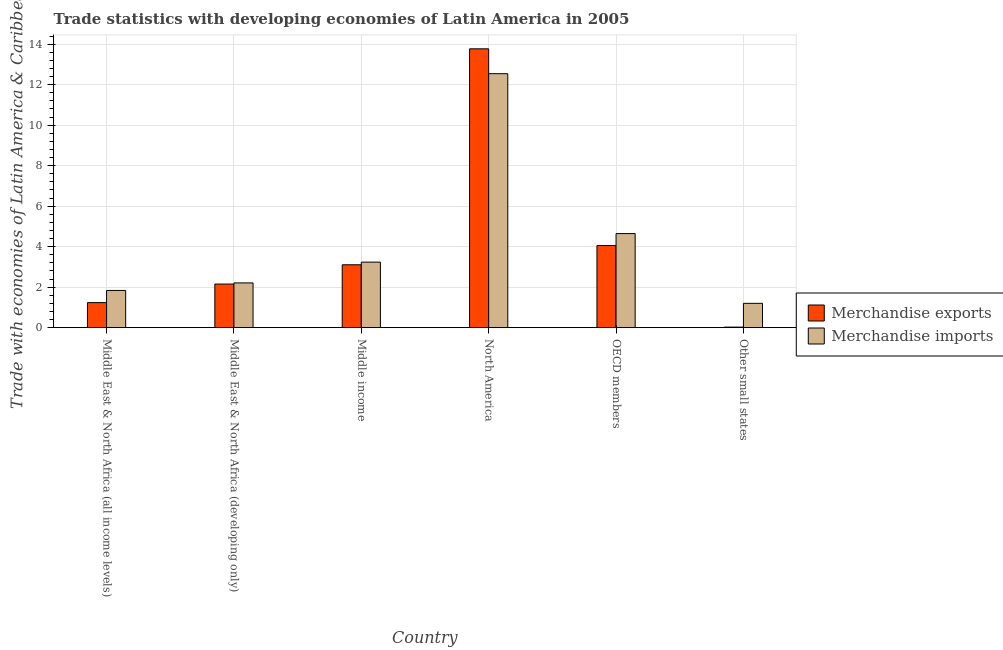How many groups of bars are there?
Your response must be concise. 6. Are the number of bars per tick equal to the number of legend labels?
Keep it short and to the point. Yes. Are the number of bars on each tick of the X-axis equal?
Make the answer very short. Yes. How many bars are there on the 4th tick from the left?
Give a very brief answer. 2. How many bars are there on the 1st tick from the right?
Your answer should be compact. 2. What is the label of the 6th group of bars from the left?
Offer a terse response. Other small states. What is the merchandise exports in Middle East & North Africa (all income levels)?
Provide a succinct answer. 1.24. Across all countries, what is the maximum merchandise exports?
Offer a terse response. 13.77. Across all countries, what is the minimum merchandise imports?
Keep it short and to the point. 1.2. In which country was the merchandise exports maximum?
Your response must be concise. North America. In which country was the merchandise imports minimum?
Keep it short and to the point. Other small states. What is the total merchandise exports in the graph?
Make the answer very short. 24.35. What is the difference between the merchandise exports in Middle East & North Africa (developing only) and that in Middle income?
Provide a succinct answer. -0.95. What is the difference between the merchandise exports in OECD members and the merchandise imports in North America?
Make the answer very short. -8.48. What is the average merchandise exports per country?
Ensure brevity in your answer.  4.06. What is the difference between the merchandise imports and merchandise exports in Middle East & North Africa (all income levels)?
Offer a terse response. 0.6. In how many countries, is the merchandise imports greater than 4 %?
Your answer should be very brief. 2. What is the ratio of the merchandise imports in Middle East & North Africa (all income levels) to that in Middle East & North Africa (developing only)?
Make the answer very short. 0.83. Is the difference between the merchandise imports in North America and Other small states greater than the difference between the merchandise exports in North America and Other small states?
Offer a terse response. No. What is the difference between the highest and the second highest merchandise imports?
Keep it short and to the point. 7.9. What is the difference between the highest and the lowest merchandise imports?
Make the answer very short. 11.34. In how many countries, is the merchandise imports greater than the average merchandise imports taken over all countries?
Your answer should be very brief. 2. Is the sum of the merchandise exports in Middle East & North Africa (developing only) and North America greater than the maximum merchandise imports across all countries?
Your answer should be very brief. Yes. What does the 1st bar from the left in OECD members represents?
Provide a succinct answer. Merchandise exports. What does the 2nd bar from the right in Middle income represents?
Ensure brevity in your answer.  Merchandise exports. How many bars are there?
Offer a terse response. 12. Are all the bars in the graph horizontal?
Give a very brief answer. No. How many countries are there in the graph?
Ensure brevity in your answer.  6. Does the graph contain any zero values?
Give a very brief answer. No. What is the title of the graph?
Your answer should be very brief. Trade statistics with developing economies of Latin America in 2005. Does "Goods and services" appear as one of the legend labels in the graph?
Give a very brief answer. No. What is the label or title of the X-axis?
Provide a succinct answer. Country. What is the label or title of the Y-axis?
Your response must be concise. Trade with economies of Latin America & Caribbean(%). What is the Trade with economies of Latin America & Caribbean(%) in Merchandise exports in Middle East & North Africa (all income levels)?
Provide a short and direct response. 1.24. What is the Trade with economies of Latin America & Caribbean(%) of Merchandise imports in Middle East & North Africa (all income levels)?
Your answer should be very brief. 1.84. What is the Trade with economies of Latin America & Caribbean(%) of Merchandise exports in Middle East & North Africa (developing only)?
Your response must be concise. 2.15. What is the Trade with economies of Latin America & Caribbean(%) in Merchandise imports in Middle East & North Africa (developing only)?
Provide a short and direct response. 2.21. What is the Trade with economies of Latin America & Caribbean(%) of Merchandise exports in Middle income?
Ensure brevity in your answer.  3.11. What is the Trade with economies of Latin America & Caribbean(%) in Merchandise imports in Middle income?
Offer a terse response. 3.24. What is the Trade with economies of Latin America & Caribbean(%) of Merchandise exports in North America?
Offer a very short reply. 13.77. What is the Trade with economies of Latin America & Caribbean(%) in Merchandise imports in North America?
Make the answer very short. 12.54. What is the Trade with economies of Latin America & Caribbean(%) of Merchandise exports in OECD members?
Provide a succinct answer. 4.06. What is the Trade with economies of Latin America & Caribbean(%) in Merchandise imports in OECD members?
Provide a short and direct response. 4.64. What is the Trade with economies of Latin America & Caribbean(%) of Merchandise exports in Other small states?
Offer a very short reply. 0.03. What is the Trade with economies of Latin America & Caribbean(%) of Merchandise imports in Other small states?
Give a very brief answer. 1.2. Across all countries, what is the maximum Trade with economies of Latin America & Caribbean(%) of Merchandise exports?
Offer a terse response. 13.77. Across all countries, what is the maximum Trade with economies of Latin America & Caribbean(%) of Merchandise imports?
Offer a terse response. 12.54. Across all countries, what is the minimum Trade with economies of Latin America & Caribbean(%) in Merchandise exports?
Give a very brief answer. 0.03. Across all countries, what is the minimum Trade with economies of Latin America & Caribbean(%) of Merchandise imports?
Provide a succinct answer. 1.2. What is the total Trade with economies of Latin America & Caribbean(%) in Merchandise exports in the graph?
Keep it short and to the point. 24.35. What is the total Trade with economies of Latin America & Caribbean(%) of Merchandise imports in the graph?
Your response must be concise. 25.67. What is the difference between the Trade with economies of Latin America & Caribbean(%) of Merchandise exports in Middle East & North Africa (all income levels) and that in Middle East & North Africa (developing only)?
Give a very brief answer. -0.92. What is the difference between the Trade with economies of Latin America & Caribbean(%) in Merchandise imports in Middle East & North Africa (all income levels) and that in Middle East & North Africa (developing only)?
Offer a very short reply. -0.37. What is the difference between the Trade with economies of Latin America & Caribbean(%) in Merchandise exports in Middle East & North Africa (all income levels) and that in Middle income?
Your answer should be very brief. -1.87. What is the difference between the Trade with economies of Latin America & Caribbean(%) of Merchandise imports in Middle East & North Africa (all income levels) and that in Middle income?
Make the answer very short. -1.4. What is the difference between the Trade with economies of Latin America & Caribbean(%) of Merchandise exports in Middle East & North Africa (all income levels) and that in North America?
Give a very brief answer. -12.53. What is the difference between the Trade with economies of Latin America & Caribbean(%) in Merchandise imports in Middle East & North Africa (all income levels) and that in North America?
Your answer should be very brief. -10.7. What is the difference between the Trade with economies of Latin America & Caribbean(%) of Merchandise exports in Middle East & North Africa (all income levels) and that in OECD members?
Offer a very short reply. -2.82. What is the difference between the Trade with economies of Latin America & Caribbean(%) in Merchandise imports in Middle East & North Africa (all income levels) and that in OECD members?
Offer a very short reply. -2.81. What is the difference between the Trade with economies of Latin America & Caribbean(%) in Merchandise exports in Middle East & North Africa (all income levels) and that in Other small states?
Ensure brevity in your answer.  1.21. What is the difference between the Trade with economies of Latin America & Caribbean(%) in Merchandise imports in Middle East & North Africa (all income levels) and that in Other small states?
Offer a very short reply. 0.64. What is the difference between the Trade with economies of Latin America & Caribbean(%) in Merchandise exports in Middle East & North Africa (developing only) and that in Middle income?
Your answer should be very brief. -0.95. What is the difference between the Trade with economies of Latin America & Caribbean(%) in Merchandise imports in Middle East & North Africa (developing only) and that in Middle income?
Give a very brief answer. -1.03. What is the difference between the Trade with economies of Latin America & Caribbean(%) in Merchandise exports in Middle East & North Africa (developing only) and that in North America?
Keep it short and to the point. -11.62. What is the difference between the Trade with economies of Latin America & Caribbean(%) of Merchandise imports in Middle East & North Africa (developing only) and that in North America?
Make the answer very short. -10.33. What is the difference between the Trade with economies of Latin America & Caribbean(%) in Merchandise exports in Middle East & North Africa (developing only) and that in OECD members?
Your answer should be compact. -1.9. What is the difference between the Trade with economies of Latin America & Caribbean(%) in Merchandise imports in Middle East & North Africa (developing only) and that in OECD members?
Offer a terse response. -2.44. What is the difference between the Trade with economies of Latin America & Caribbean(%) of Merchandise exports in Middle East & North Africa (developing only) and that in Other small states?
Give a very brief answer. 2.13. What is the difference between the Trade with economies of Latin America & Caribbean(%) in Merchandise imports in Middle East & North Africa (developing only) and that in Other small states?
Your response must be concise. 1.01. What is the difference between the Trade with economies of Latin America & Caribbean(%) of Merchandise exports in Middle income and that in North America?
Provide a succinct answer. -10.66. What is the difference between the Trade with economies of Latin America & Caribbean(%) in Merchandise imports in Middle income and that in North America?
Offer a very short reply. -9.31. What is the difference between the Trade with economies of Latin America & Caribbean(%) of Merchandise exports in Middle income and that in OECD members?
Offer a terse response. -0.95. What is the difference between the Trade with economies of Latin America & Caribbean(%) in Merchandise imports in Middle income and that in OECD members?
Provide a short and direct response. -1.41. What is the difference between the Trade with economies of Latin America & Caribbean(%) of Merchandise exports in Middle income and that in Other small states?
Give a very brief answer. 3.08. What is the difference between the Trade with economies of Latin America & Caribbean(%) in Merchandise imports in Middle income and that in Other small states?
Your response must be concise. 2.03. What is the difference between the Trade with economies of Latin America & Caribbean(%) of Merchandise exports in North America and that in OECD members?
Make the answer very short. 9.71. What is the difference between the Trade with economies of Latin America & Caribbean(%) in Merchandise imports in North America and that in OECD members?
Offer a terse response. 7.9. What is the difference between the Trade with economies of Latin America & Caribbean(%) in Merchandise exports in North America and that in Other small states?
Offer a very short reply. 13.74. What is the difference between the Trade with economies of Latin America & Caribbean(%) of Merchandise imports in North America and that in Other small states?
Offer a terse response. 11.34. What is the difference between the Trade with economies of Latin America & Caribbean(%) in Merchandise exports in OECD members and that in Other small states?
Offer a very short reply. 4.03. What is the difference between the Trade with economies of Latin America & Caribbean(%) in Merchandise imports in OECD members and that in Other small states?
Ensure brevity in your answer.  3.44. What is the difference between the Trade with economies of Latin America & Caribbean(%) of Merchandise exports in Middle East & North Africa (all income levels) and the Trade with economies of Latin America & Caribbean(%) of Merchandise imports in Middle East & North Africa (developing only)?
Ensure brevity in your answer.  -0.97. What is the difference between the Trade with economies of Latin America & Caribbean(%) in Merchandise exports in Middle East & North Africa (all income levels) and the Trade with economies of Latin America & Caribbean(%) in Merchandise imports in Middle income?
Keep it short and to the point. -2. What is the difference between the Trade with economies of Latin America & Caribbean(%) in Merchandise exports in Middle East & North Africa (all income levels) and the Trade with economies of Latin America & Caribbean(%) in Merchandise imports in North America?
Your answer should be compact. -11.3. What is the difference between the Trade with economies of Latin America & Caribbean(%) of Merchandise exports in Middle East & North Africa (all income levels) and the Trade with economies of Latin America & Caribbean(%) of Merchandise imports in OECD members?
Provide a short and direct response. -3.41. What is the difference between the Trade with economies of Latin America & Caribbean(%) of Merchandise exports in Middle East & North Africa (all income levels) and the Trade with economies of Latin America & Caribbean(%) of Merchandise imports in Other small states?
Provide a short and direct response. 0.04. What is the difference between the Trade with economies of Latin America & Caribbean(%) in Merchandise exports in Middle East & North Africa (developing only) and the Trade with economies of Latin America & Caribbean(%) in Merchandise imports in Middle income?
Make the answer very short. -1.08. What is the difference between the Trade with economies of Latin America & Caribbean(%) in Merchandise exports in Middle East & North Africa (developing only) and the Trade with economies of Latin America & Caribbean(%) in Merchandise imports in North America?
Give a very brief answer. -10.39. What is the difference between the Trade with economies of Latin America & Caribbean(%) of Merchandise exports in Middle East & North Africa (developing only) and the Trade with economies of Latin America & Caribbean(%) of Merchandise imports in OECD members?
Your response must be concise. -2.49. What is the difference between the Trade with economies of Latin America & Caribbean(%) in Merchandise exports in Middle East & North Africa (developing only) and the Trade with economies of Latin America & Caribbean(%) in Merchandise imports in Other small states?
Ensure brevity in your answer.  0.95. What is the difference between the Trade with economies of Latin America & Caribbean(%) of Merchandise exports in Middle income and the Trade with economies of Latin America & Caribbean(%) of Merchandise imports in North America?
Provide a short and direct response. -9.44. What is the difference between the Trade with economies of Latin America & Caribbean(%) in Merchandise exports in Middle income and the Trade with economies of Latin America & Caribbean(%) in Merchandise imports in OECD members?
Offer a terse response. -1.54. What is the difference between the Trade with economies of Latin America & Caribbean(%) in Merchandise exports in Middle income and the Trade with economies of Latin America & Caribbean(%) in Merchandise imports in Other small states?
Provide a succinct answer. 1.9. What is the difference between the Trade with economies of Latin America & Caribbean(%) of Merchandise exports in North America and the Trade with economies of Latin America & Caribbean(%) of Merchandise imports in OECD members?
Provide a short and direct response. 9.12. What is the difference between the Trade with economies of Latin America & Caribbean(%) in Merchandise exports in North America and the Trade with economies of Latin America & Caribbean(%) in Merchandise imports in Other small states?
Offer a terse response. 12.57. What is the difference between the Trade with economies of Latin America & Caribbean(%) in Merchandise exports in OECD members and the Trade with economies of Latin America & Caribbean(%) in Merchandise imports in Other small states?
Your response must be concise. 2.85. What is the average Trade with economies of Latin America & Caribbean(%) in Merchandise exports per country?
Your response must be concise. 4.06. What is the average Trade with economies of Latin America & Caribbean(%) in Merchandise imports per country?
Your answer should be very brief. 4.28. What is the difference between the Trade with economies of Latin America & Caribbean(%) in Merchandise exports and Trade with economies of Latin America & Caribbean(%) in Merchandise imports in Middle East & North Africa (all income levels)?
Offer a very short reply. -0.6. What is the difference between the Trade with economies of Latin America & Caribbean(%) of Merchandise exports and Trade with economies of Latin America & Caribbean(%) of Merchandise imports in Middle East & North Africa (developing only)?
Give a very brief answer. -0.06. What is the difference between the Trade with economies of Latin America & Caribbean(%) of Merchandise exports and Trade with economies of Latin America & Caribbean(%) of Merchandise imports in Middle income?
Keep it short and to the point. -0.13. What is the difference between the Trade with economies of Latin America & Caribbean(%) of Merchandise exports and Trade with economies of Latin America & Caribbean(%) of Merchandise imports in North America?
Keep it short and to the point. 1.23. What is the difference between the Trade with economies of Latin America & Caribbean(%) of Merchandise exports and Trade with economies of Latin America & Caribbean(%) of Merchandise imports in OECD members?
Offer a very short reply. -0.59. What is the difference between the Trade with economies of Latin America & Caribbean(%) in Merchandise exports and Trade with economies of Latin America & Caribbean(%) in Merchandise imports in Other small states?
Keep it short and to the point. -1.17. What is the ratio of the Trade with economies of Latin America & Caribbean(%) of Merchandise exports in Middle East & North Africa (all income levels) to that in Middle East & North Africa (developing only)?
Give a very brief answer. 0.57. What is the ratio of the Trade with economies of Latin America & Caribbean(%) in Merchandise imports in Middle East & North Africa (all income levels) to that in Middle East & North Africa (developing only)?
Provide a short and direct response. 0.83. What is the ratio of the Trade with economies of Latin America & Caribbean(%) in Merchandise exports in Middle East & North Africa (all income levels) to that in Middle income?
Your response must be concise. 0.4. What is the ratio of the Trade with economies of Latin America & Caribbean(%) of Merchandise imports in Middle East & North Africa (all income levels) to that in Middle income?
Keep it short and to the point. 0.57. What is the ratio of the Trade with economies of Latin America & Caribbean(%) of Merchandise exports in Middle East & North Africa (all income levels) to that in North America?
Your response must be concise. 0.09. What is the ratio of the Trade with economies of Latin America & Caribbean(%) in Merchandise imports in Middle East & North Africa (all income levels) to that in North America?
Your answer should be very brief. 0.15. What is the ratio of the Trade with economies of Latin America & Caribbean(%) of Merchandise exports in Middle East & North Africa (all income levels) to that in OECD members?
Make the answer very short. 0.3. What is the ratio of the Trade with economies of Latin America & Caribbean(%) of Merchandise imports in Middle East & North Africa (all income levels) to that in OECD members?
Your response must be concise. 0.4. What is the ratio of the Trade with economies of Latin America & Caribbean(%) in Merchandise exports in Middle East & North Africa (all income levels) to that in Other small states?
Your answer should be compact. 45.52. What is the ratio of the Trade with economies of Latin America & Caribbean(%) in Merchandise imports in Middle East & North Africa (all income levels) to that in Other small states?
Provide a short and direct response. 1.53. What is the ratio of the Trade with economies of Latin America & Caribbean(%) in Merchandise exports in Middle East & North Africa (developing only) to that in Middle income?
Provide a succinct answer. 0.69. What is the ratio of the Trade with economies of Latin America & Caribbean(%) of Merchandise imports in Middle East & North Africa (developing only) to that in Middle income?
Ensure brevity in your answer.  0.68. What is the ratio of the Trade with economies of Latin America & Caribbean(%) of Merchandise exports in Middle East & North Africa (developing only) to that in North America?
Provide a short and direct response. 0.16. What is the ratio of the Trade with economies of Latin America & Caribbean(%) of Merchandise imports in Middle East & North Africa (developing only) to that in North America?
Keep it short and to the point. 0.18. What is the ratio of the Trade with economies of Latin America & Caribbean(%) in Merchandise exports in Middle East & North Africa (developing only) to that in OECD members?
Ensure brevity in your answer.  0.53. What is the ratio of the Trade with economies of Latin America & Caribbean(%) of Merchandise imports in Middle East & North Africa (developing only) to that in OECD members?
Your answer should be compact. 0.48. What is the ratio of the Trade with economies of Latin America & Caribbean(%) of Merchandise exports in Middle East & North Africa (developing only) to that in Other small states?
Your response must be concise. 79.25. What is the ratio of the Trade with economies of Latin America & Caribbean(%) of Merchandise imports in Middle East & North Africa (developing only) to that in Other small states?
Offer a very short reply. 1.84. What is the ratio of the Trade with economies of Latin America & Caribbean(%) in Merchandise exports in Middle income to that in North America?
Offer a terse response. 0.23. What is the ratio of the Trade with economies of Latin America & Caribbean(%) of Merchandise imports in Middle income to that in North America?
Give a very brief answer. 0.26. What is the ratio of the Trade with economies of Latin America & Caribbean(%) of Merchandise exports in Middle income to that in OECD members?
Give a very brief answer. 0.77. What is the ratio of the Trade with economies of Latin America & Caribbean(%) of Merchandise imports in Middle income to that in OECD members?
Give a very brief answer. 0.7. What is the ratio of the Trade with economies of Latin America & Caribbean(%) in Merchandise exports in Middle income to that in Other small states?
Your answer should be very brief. 114.31. What is the ratio of the Trade with economies of Latin America & Caribbean(%) in Merchandise imports in Middle income to that in Other small states?
Your response must be concise. 2.69. What is the ratio of the Trade with economies of Latin America & Caribbean(%) in Merchandise exports in North America to that in OECD members?
Ensure brevity in your answer.  3.39. What is the ratio of the Trade with economies of Latin America & Caribbean(%) of Merchandise imports in North America to that in OECD members?
Give a very brief answer. 2.7. What is the ratio of the Trade with economies of Latin America & Caribbean(%) of Merchandise exports in North America to that in Other small states?
Keep it short and to the point. 506.82. What is the ratio of the Trade with economies of Latin America & Caribbean(%) in Merchandise imports in North America to that in Other small states?
Offer a very short reply. 10.44. What is the ratio of the Trade with economies of Latin America & Caribbean(%) in Merchandise exports in OECD members to that in Other small states?
Your answer should be compact. 149.31. What is the ratio of the Trade with economies of Latin America & Caribbean(%) of Merchandise imports in OECD members to that in Other small states?
Make the answer very short. 3.87. What is the difference between the highest and the second highest Trade with economies of Latin America & Caribbean(%) of Merchandise exports?
Keep it short and to the point. 9.71. What is the difference between the highest and the second highest Trade with economies of Latin America & Caribbean(%) in Merchandise imports?
Your response must be concise. 7.9. What is the difference between the highest and the lowest Trade with economies of Latin America & Caribbean(%) in Merchandise exports?
Offer a very short reply. 13.74. What is the difference between the highest and the lowest Trade with economies of Latin America & Caribbean(%) of Merchandise imports?
Your answer should be compact. 11.34. 